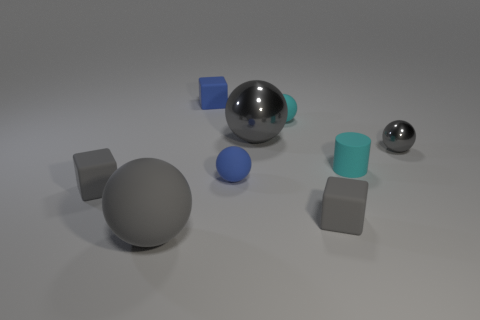Subtract all brown blocks. How many gray balls are left? 3 Subtract all gray rubber balls. How many balls are left? 4 Subtract all cyan spheres. How many spheres are left? 4 Subtract all purple spheres. Subtract all cyan cylinders. How many spheres are left? 5 Subtract all spheres. How many objects are left? 4 Add 7 tiny gray shiny things. How many tiny gray shiny things exist? 8 Subtract 0 brown cubes. How many objects are left? 9 Subtract all shiny things. Subtract all tiny blue cubes. How many objects are left? 6 Add 2 blue things. How many blue things are left? 4 